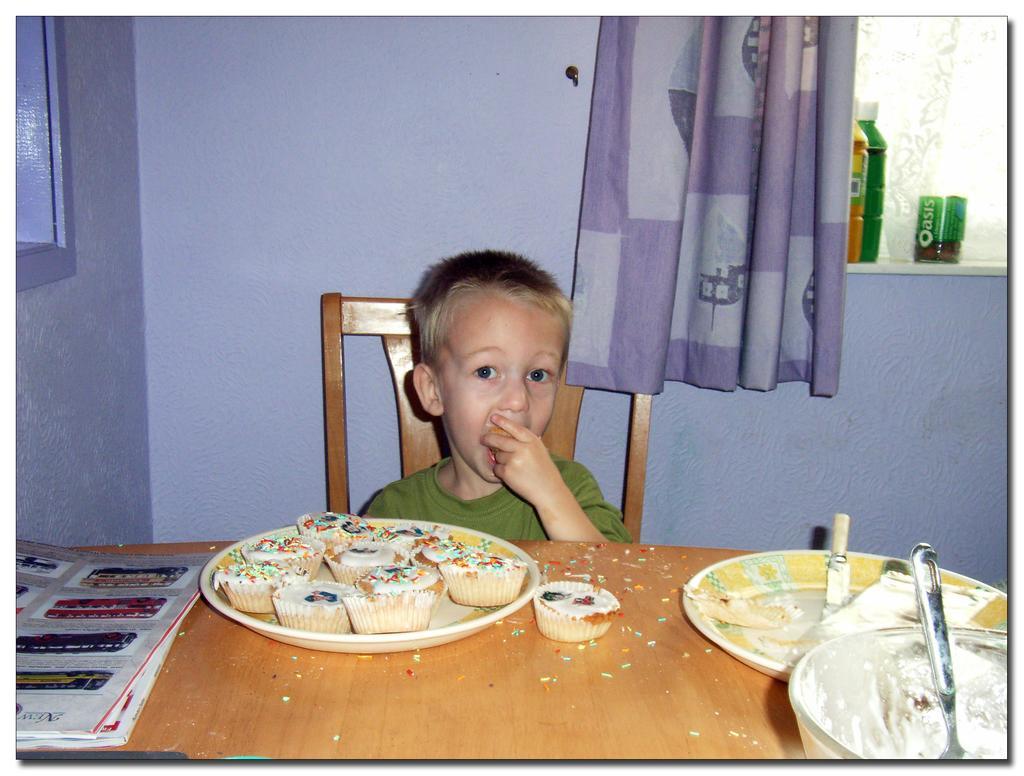Describe this image in one or two sentences. In this image a boy is sitting on the chair. Before him there is a table having books, plates and a cupcake. On the plate there are cupcakes. Right bottom there is a bowl, having a spoon. Behind there is a plate having a knife on it. Background there is a wall having windows. Right side bottles and an object are kept on the shelf. There is a curtain. 